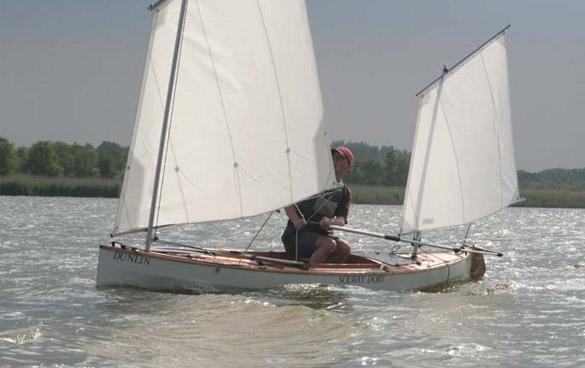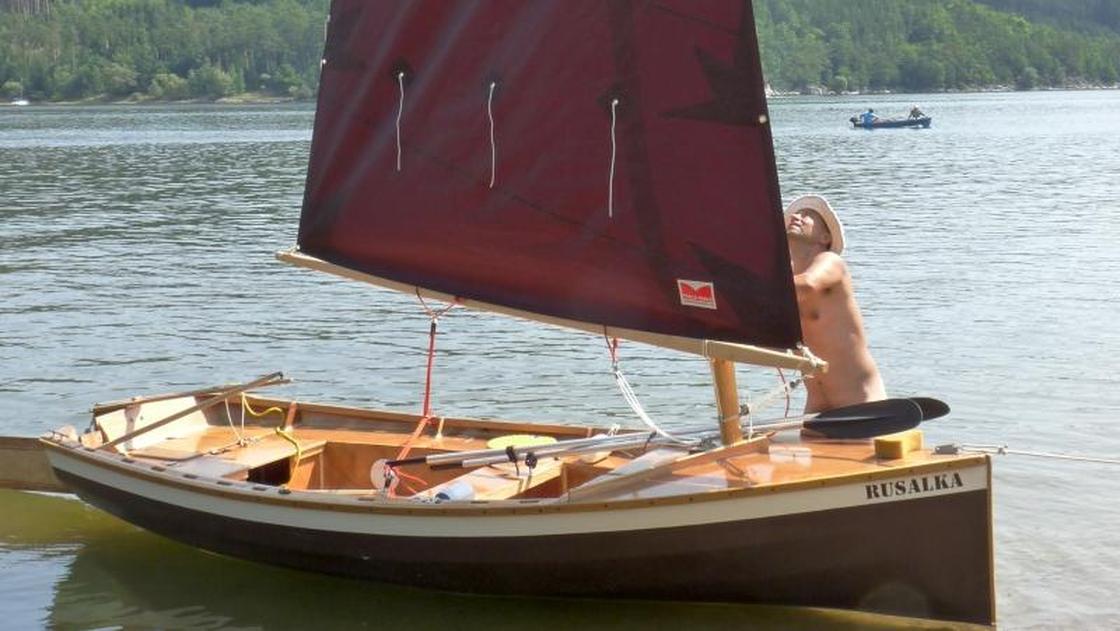The first image is the image on the left, the second image is the image on the right. Examine the images to the left and right. Is the description "In the left image there is a person in a boat wearing a hate with two raised sails" accurate? Answer yes or no. Yes. The first image is the image on the left, the second image is the image on the right. Assess this claim about the two images: "All the sails are white.". Correct or not? Answer yes or no. No. 